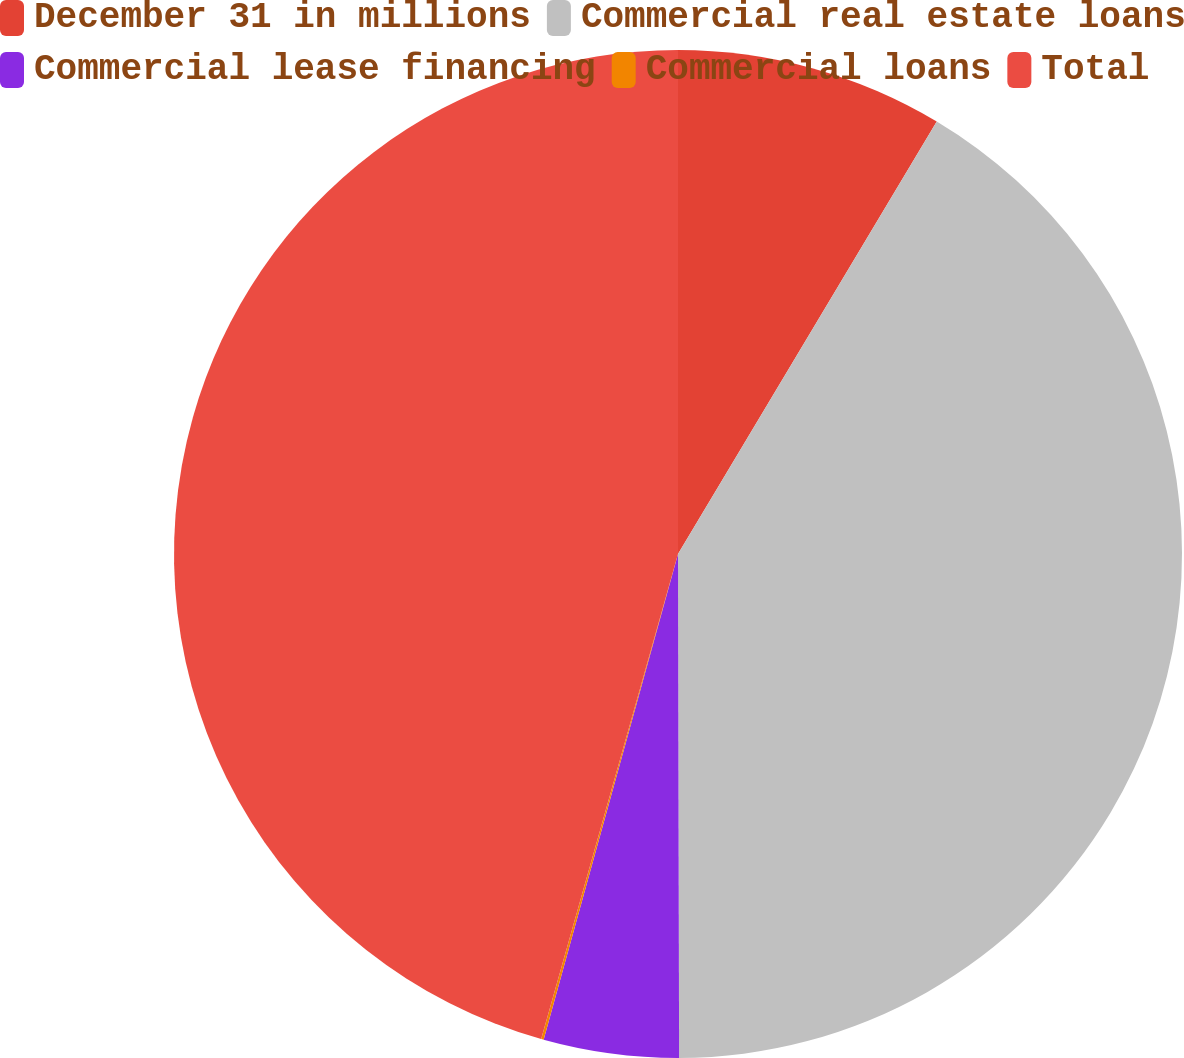<chart> <loc_0><loc_0><loc_500><loc_500><pie_chart><fcel>December 31 in millions<fcel>Commercial real estate loans<fcel>Commercial lease financing<fcel>Commercial loans<fcel>Total<nl><fcel>8.58%<fcel>41.38%<fcel>4.33%<fcel>0.08%<fcel>45.62%<nl></chart> 